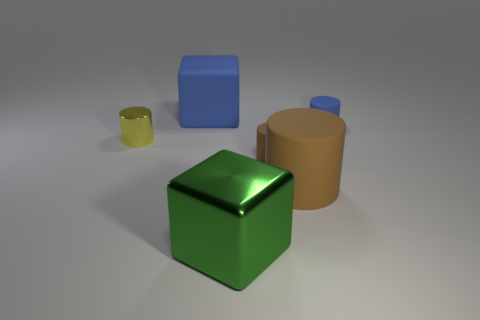There is a tiny matte object that is the same color as the matte cube; what is its shape?
Offer a terse response. Cylinder. What is the size of the other matte cylinder that is the same color as the large rubber cylinder?
Your answer should be compact. Small. What is the block in front of the tiny blue rubber cylinder made of?
Offer a very short reply. Metal. Do the small metallic thing and the green shiny object have the same shape?
Your answer should be compact. No. What number of other objects are the same shape as the large metal object?
Your answer should be very brief. 1. What is the color of the metal thing that is in front of the yellow shiny cylinder?
Keep it short and to the point. Green. Is the green thing the same size as the blue cube?
Keep it short and to the point. Yes. There is a blue thing in front of the blue thing that is on the left side of the green shiny thing; what is it made of?
Ensure brevity in your answer.  Rubber. What number of small cylinders are the same color as the tiny metal object?
Offer a very short reply. 0. Are there any other things that are the same material as the green object?
Your response must be concise. Yes. 